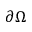<formula> <loc_0><loc_0><loc_500><loc_500>\partial \Omega</formula> 